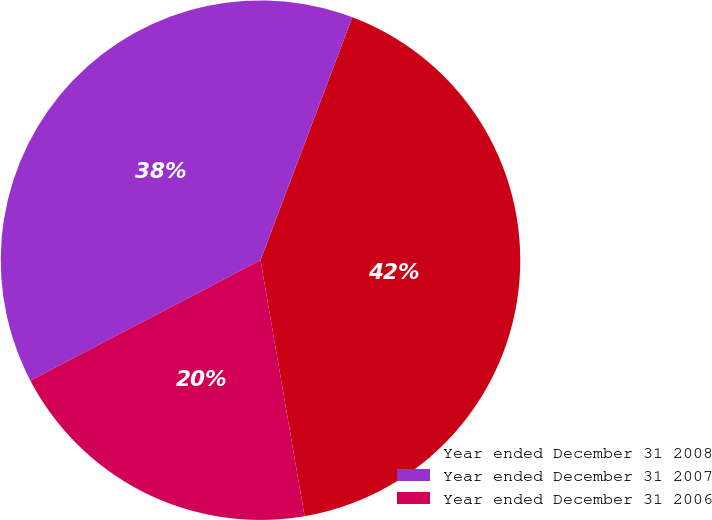<chart> <loc_0><loc_0><loc_500><loc_500><pie_chart><fcel>Year ended December 31 2008<fcel>Year ended December 31 2007<fcel>Year ended December 31 2006<nl><fcel>41.54%<fcel>38.43%<fcel>20.04%<nl></chart> 